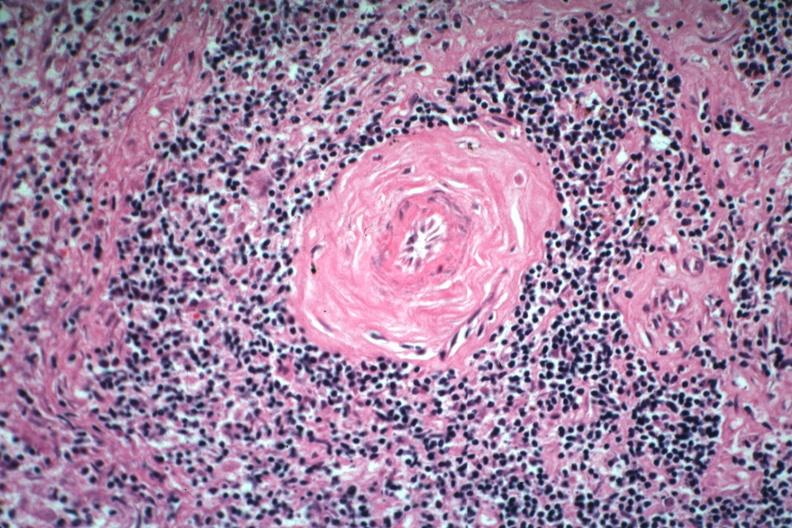s hematologic present?
Answer the question using a single word or phrase. Yes 